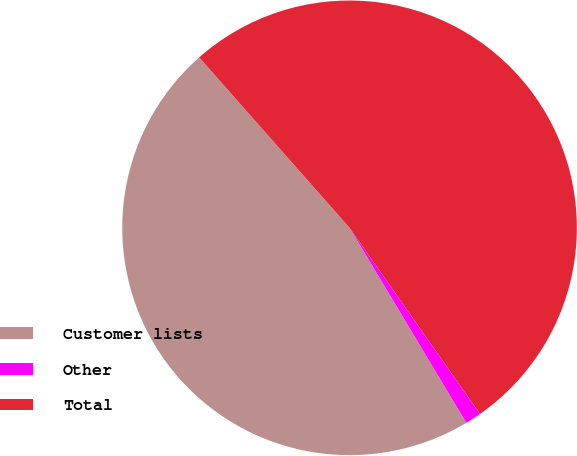<chart> <loc_0><loc_0><loc_500><loc_500><pie_chart><fcel>Customer lists<fcel>Other<fcel>Total<nl><fcel>47.08%<fcel>1.14%<fcel>51.78%<nl></chart> 